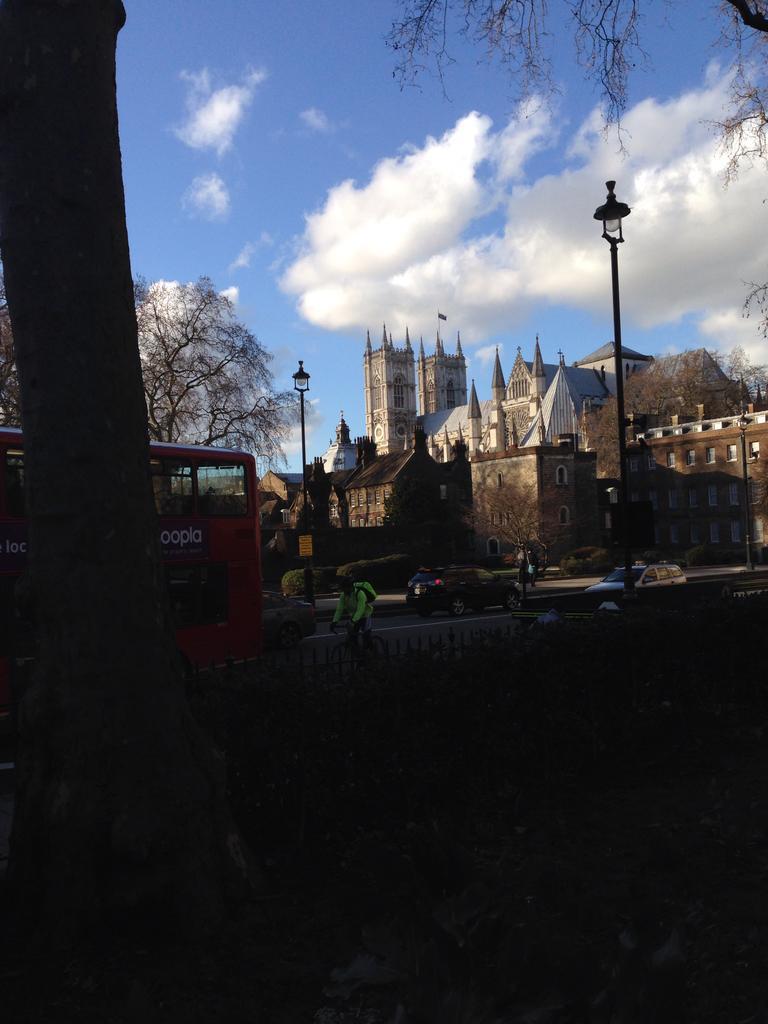Could you give a brief overview of what you see in this image? In this picture I can see there are few vehicles moving on the road, there are few buildings, it has few windows and trees. The sky is clear. 